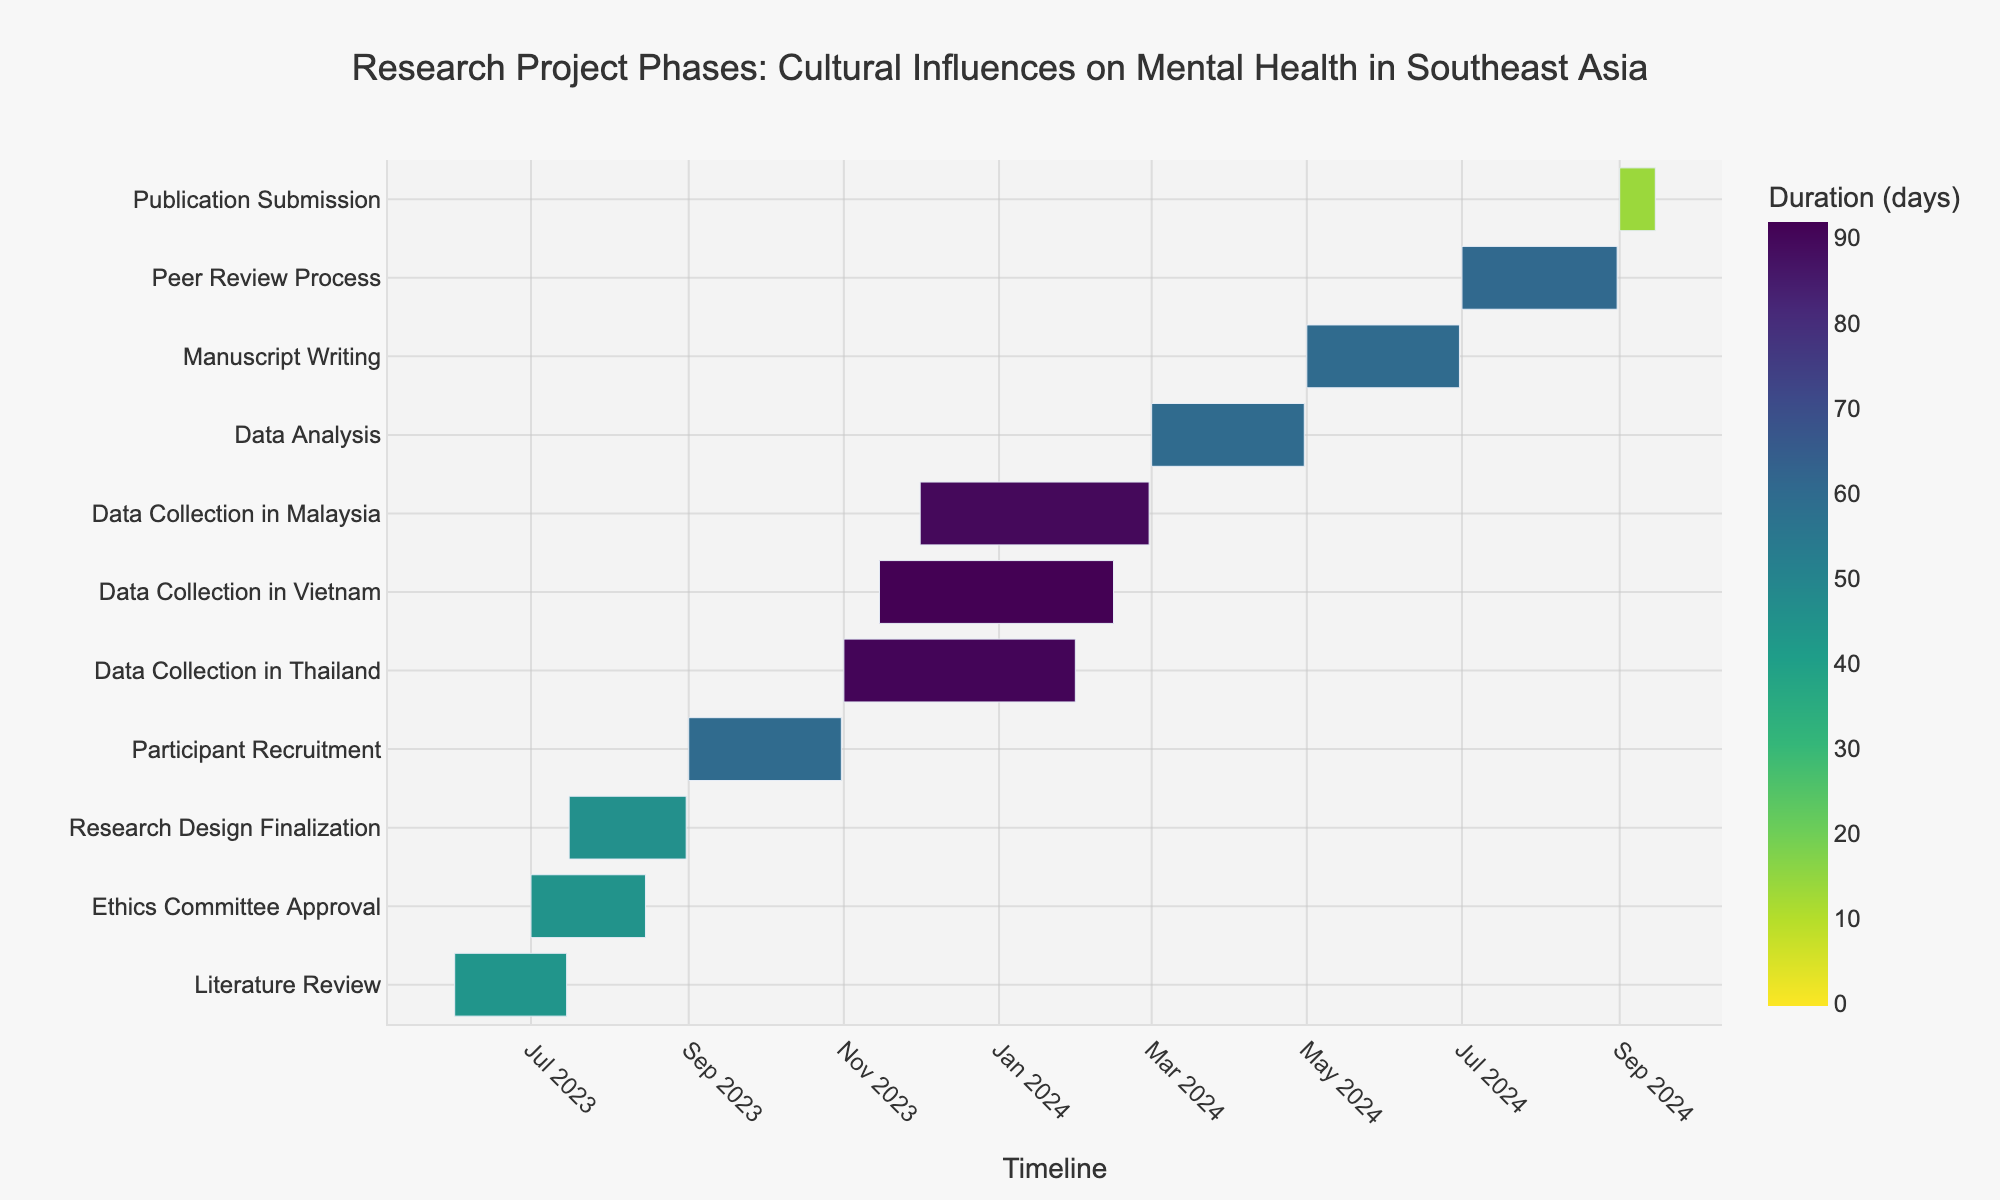When does the Literature Review phase start and end? The Literature Review phase starts on June 1, 2023, and ends on July 15, 2023. This information is found by looking at the start and end dates for the Literature Review task on the y-axis.
Answer: June 1, 2023 - July 15, 2023 What is the duration of the Data Collection in Thailand phase? To find the duration of the Data Collection in Thailand phase, subtract the start date from the end date. The start date is November 1, 2023, and the end date is January 31, 2024. The duration is (January 31, 2024 - November 1, 2023).
Answer: 92 days How does the duration of Participant Recruitment compare to the Data Analysis phase? The Participant Recruitment phase runs from September 1, 2023, to October 31, 2023, lasting 61 days. The Data Analysis phase runs from March 1, 2024, to April 30, 2024, lasting 61 days. By comparing, both phases have the same duration.
Answer: Same duration Which Data Collection phase lasts the longest, and what is its duration? To identify the longest Data Collection phase, compare the durations: Thailand (92 days), Vietnam (93 days), and Malaysia (91 days). Vietnam has the longest phase.
Answer: Vietnam, 93 days Which two phases overlap with the Ethics Committee Approval phase? The Ethics Committee Approval phase runs from July 1, 2023, to August 15, 2023. The overlapping phases are Literature Review (June 1, 2023 - July 15, 2023) and Research Design Finalization (July 16, 2023 - August 31, 2023).
Answer: Literature Review and Research Design Finalization What is the total duration from the start to the end of the entire research project? The entire project starts with the Literature Review on June 1, 2023, and ends with the Publication Submission on September 15, 2024. Adding the durations of each task gives the total duration. But to simplify, count the days from June 1, 2023, to September 15, 2024. This equals 472 days.
Answer: 472 days At which point do the Data Collection phases in Thailand, Vietnam, and Malaysia all overlap? The overlapping point must be within the shared timeframe of all three durations: Thailand (November 1, 2023 - January 31, 2024), Vietnam (November 15, 2023 - February 15, 2024), and Malaysia (December 1, 2023 - February 29, 2024). They overlap from December 1, 2023, to January 31, 2024.
Answer: December 1, 2023 - January 31, 2024 